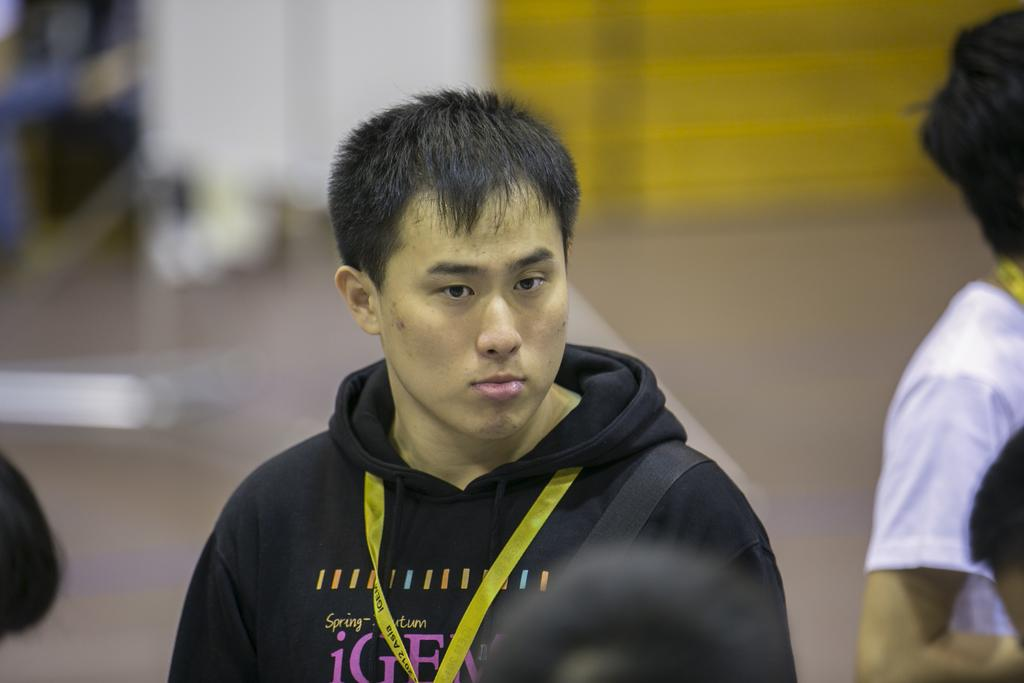What is the main subject of the image? There is a man standing in the image. What is the man wearing? The man is wearing a hoodie. Is there anything unusual about the man's appearance? Yes, there is a yellow color tag around the man's neck. Are there any other people in the image? Yes, there are other people standing in the image. What type of thrill can be seen on the man's feet in the image? There is no indication of any thrill or excitement on the man's feet in the image. 